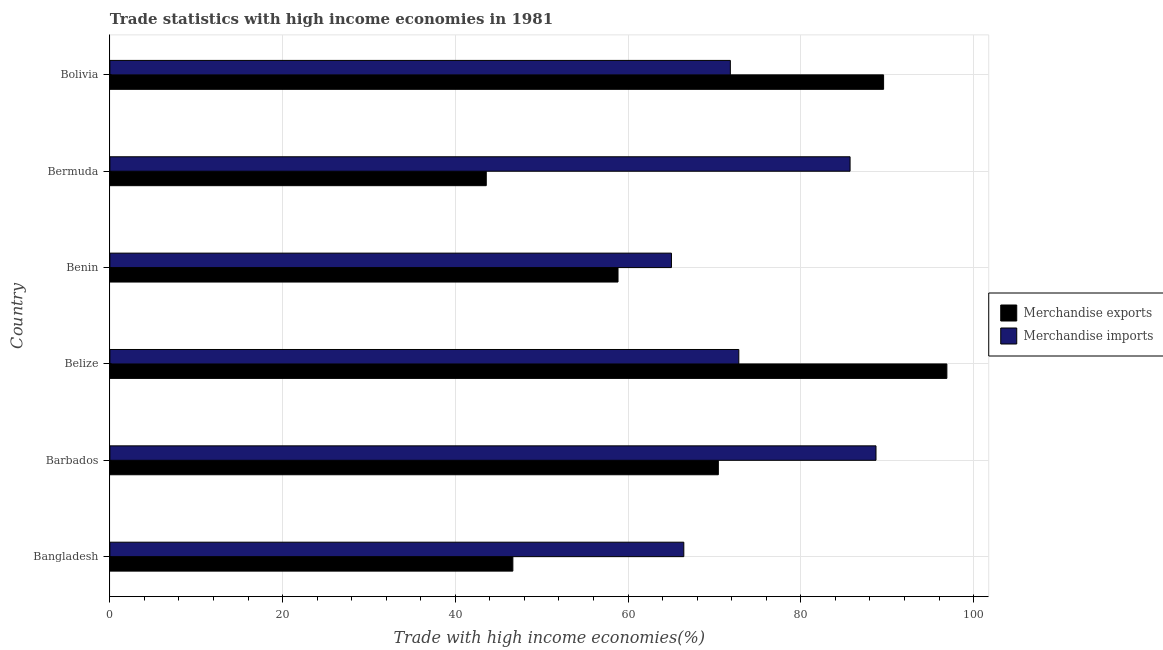How many groups of bars are there?
Give a very brief answer. 6. Are the number of bars on each tick of the Y-axis equal?
Provide a succinct answer. Yes. How many bars are there on the 1st tick from the bottom?
Offer a very short reply. 2. What is the label of the 1st group of bars from the top?
Offer a very short reply. Bolivia. In how many cases, is the number of bars for a given country not equal to the number of legend labels?
Your answer should be compact. 0. What is the merchandise imports in Bermuda?
Offer a terse response. 85.7. Across all countries, what is the maximum merchandise imports?
Give a very brief answer. 88.7. Across all countries, what is the minimum merchandise imports?
Ensure brevity in your answer.  65.02. In which country was the merchandise imports maximum?
Offer a very short reply. Barbados. In which country was the merchandise exports minimum?
Provide a short and direct response. Bermuda. What is the total merchandise exports in the graph?
Give a very brief answer. 406.02. What is the difference between the merchandise exports in Bangladesh and that in Belize?
Provide a short and direct response. -50.25. What is the difference between the merchandise imports in Benin and the merchandise exports in Belize?
Keep it short and to the point. -31.89. What is the average merchandise exports per country?
Your response must be concise. 67.67. What is the difference between the merchandise imports and merchandise exports in Barbados?
Your response must be concise. 18.25. What is the ratio of the merchandise imports in Barbados to that in Bolivia?
Ensure brevity in your answer.  1.24. Is the merchandise imports in Barbados less than that in Bolivia?
Provide a succinct answer. No. Is the difference between the merchandise exports in Belize and Bermuda greater than the difference between the merchandise imports in Belize and Bermuda?
Offer a very short reply. Yes. What is the difference between the highest and the second highest merchandise imports?
Provide a short and direct response. 3. What is the difference between the highest and the lowest merchandise imports?
Provide a short and direct response. 23.68. Is the sum of the merchandise imports in Bangladesh and Bolivia greater than the maximum merchandise exports across all countries?
Keep it short and to the point. Yes. What does the 2nd bar from the top in Barbados represents?
Ensure brevity in your answer.  Merchandise exports. How many bars are there?
Ensure brevity in your answer.  12. Are all the bars in the graph horizontal?
Provide a short and direct response. Yes. How many countries are there in the graph?
Your response must be concise. 6. Are the values on the major ticks of X-axis written in scientific E-notation?
Keep it short and to the point. No. Where does the legend appear in the graph?
Make the answer very short. Center right. How many legend labels are there?
Your response must be concise. 2. What is the title of the graph?
Provide a succinct answer. Trade statistics with high income economies in 1981. Does "Non-resident workers" appear as one of the legend labels in the graph?
Your answer should be compact. No. What is the label or title of the X-axis?
Provide a short and direct response. Trade with high income economies(%). What is the label or title of the Y-axis?
Your answer should be very brief. Country. What is the Trade with high income economies(%) in Merchandise exports in Bangladesh?
Offer a very short reply. 46.66. What is the Trade with high income economies(%) in Merchandise imports in Bangladesh?
Make the answer very short. 66.45. What is the Trade with high income economies(%) in Merchandise exports in Barbados?
Provide a short and direct response. 70.45. What is the Trade with high income economies(%) of Merchandise imports in Barbados?
Provide a short and direct response. 88.7. What is the Trade with high income economies(%) in Merchandise exports in Belize?
Provide a succinct answer. 96.91. What is the Trade with high income economies(%) of Merchandise imports in Belize?
Make the answer very short. 72.82. What is the Trade with high income economies(%) in Merchandise exports in Benin?
Ensure brevity in your answer.  58.83. What is the Trade with high income economies(%) in Merchandise imports in Benin?
Offer a terse response. 65.02. What is the Trade with high income economies(%) of Merchandise exports in Bermuda?
Offer a very short reply. 43.58. What is the Trade with high income economies(%) of Merchandise imports in Bermuda?
Offer a terse response. 85.7. What is the Trade with high income economies(%) in Merchandise exports in Bolivia?
Keep it short and to the point. 89.58. What is the Trade with high income economies(%) of Merchandise imports in Bolivia?
Ensure brevity in your answer.  71.84. Across all countries, what is the maximum Trade with high income economies(%) in Merchandise exports?
Your answer should be very brief. 96.91. Across all countries, what is the maximum Trade with high income economies(%) of Merchandise imports?
Make the answer very short. 88.7. Across all countries, what is the minimum Trade with high income economies(%) of Merchandise exports?
Your response must be concise. 43.58. Across all countries, what is the minimum Trade with high income economies(%) in Merchandise imports?
Make the answer very short. 65.02. What is the total Trade with high income economies(%) in Merchandise exports in the graph?
Ensure brevity in your answer.  406.02. What is the total Trade with high income economies(%) of Merchandise imports in the graph?
Provide a short and direct response. 450.54. What is the difference between the Trade with high income economies(%) of Merchandise exports in Bangladesh and that in Barbados?
Give a very brief answer. -23.79. What is the difference between the Trade with high income economies(%) of Merchandise imports in Bangladesh and that in Barbados?
Your answer should be very brief. -22.25. What is the difference between the Trade with high income economies(%) of Merchandise exports in Bangladesh and that in Belize?
Keep it short and to the point. -50.25. What is the difference between the Trade with high income economies(%) of Merchandise imports in Bangladesh and that in Belize?
Offer a very short reply. -6.37. What is the difference between the Trade with high income economies(%) of Merchandise exports in Bangladesh and that in Benin?
Make the answer very short. -12.18. What is the difference between the Trade with high income economies(%) in Merchandise imports in Bangladesh and that in Benin?
Make the answer very short. 1.43. What is the difference between the Trade with high income economies(%) in Merchandise exports in Bangladesh and that in Bermuda?
Offer a terse response. 3.08. What is the difference between the Trade with high income economies(%) of Merchandise imports in Bangladesh and that in Bermuda?
Your answer should be very brief. -19.25. What is the difference between the Trade with high income economies(%) of Merchandise exports in Bangladesh and that in Bolivia?
Give a very brief answer. -42.93. What is the difference between the Trade with high income economies(%) of Merchandise imports in Bangladesh and that in Bolivia?
Your response must be concise. -5.39. What is the difference between the Trade with high income economies(%) in Merchandise exports in Barbados and that in Belize?
Keep it short and to the point. -26.46. What is the difference between the Trade with high income economies(%) in Merchandise imports in Barbados and that in Belize?
Give a very brief answer. 15.88. What is the difference between the Trade with high income economies(%) of Merchandise exports in Barbados and that in Benin?
Ensure brevity in your answer.  11.62. What is the difference between the Trade with high income economies(%) in Merchandise imports in Barbados and that in Benin?
Give a very brief answer. 23.68. What is the difference between the Trade with high income economies(%) of Merchandise exports in Barbados and that in Bermuda?
Offer a very short reply. 26.87. What is the difference between the Trade with high income economies(%) in Merchandise imports in Barbados and that in Bermuda?
Provide a short and direct response. 3. What is the difference between the Trade with high income economies(%) in Merchandise exports in Barbados and that in Bolivia?
Your response must be concise. -19.13. What is the difference between the Trade with high income economies(%) of Merchandise imports in Barbados and that in Bolivia?
Keep it short and to the point. 16.86. What is the difference between the Trade with high income economies(%) of Merchandise exports in Belize and that in Benin?
Your response must be concise. 38.08. What is the difference between the Trade with high income economies(%) in Merchandise imports in Belize and that in Benin?
Offer a very short reply. 7.8. What is the difference between the Trade with high income economies(%) of Merchandise exports in Belize and that in Bermuda?
Your response must be concise. 53.33. What is the difference between the Trade with high income economies(%) of Merchandise imports in Belize and that in Bermuda?
Ensure brevity in your answer.  -12.88. What is the difference between the Trade with high income economies(%) of Merchandise exports in Belize and that in Bolivia?
Give a very brief answer. 7.33. What is the difference between the Trade with high income economies(%) in Merchandise imports in Belize and that in Bolivia?
Offer a very short reply. 0.98. What is the difference between the Trade with high income economies(%) of Merchandise exports in Benin and that in Bermuda?
Your answer should be compact. 15.26. What is the difference between the Trade with high income economies(%) of Merchandise imports in Benin and that in Bermuda?
Your response must be concise. -20.68. What is the difference between the Trade with high income economies(%) of Merchandise exports in Benin and that in Bolivia?
Make the answer very short. -30.75. What is the difference between the Trade with high income economies(%) of Merchandise imports in Benin and that in Bolivia?
Your answer should be very brief. -6.82. What is the difference between the Trade with high income economies(%) of Merchandise exports in Bermuda and that in Bolivia?
Make the answer very short. -46.01. What is the difference between the Trade with high income economies(%) of Merchandise imports in Bermuda and that in Bolivia?
Provide a succinct answer. 13.86. What is the difference between the Trade with high income economies(%) of Merchandise exports in Bangladesh and the Trade with high income economies(%) of Merchandise imports in Barbados?
Your answer should be very brief. -42.05. What is the difference between the Trade with high income economies(%) in Merchandise exports in Bangladesh and the Trade with high income economies(%) in Merchandise imports in Belize?
Your answer should be compact. -26.16. What is the difference between the Trade with high income economies(%) in Merchandise exports in Bangladesh and the Trade with high income economies(%) in Merchandise imports in Benin?
Your response must be concise. -18.36. What is the difference between the Trade with high income economies(%) of Merchandise exports in Bangladesh and the Trade with high income economies(%) of Merchandise imports in Bermuda?
Ensure brevity in your answer.  -39.05. What is the difference between the Trade with high income economies(%) of Merchandise exports in Bangladesh and the Trade with high income economies(%) of Merchandise imports in Bolivia?
Offer a terse response. -25.18. What is the difference between the Trade with high income economies(%) of Merchandise exports in Barbados and the Trade with high income economies(%) of Merchandise imports in Belize?
Offer a terse response. -2.37. What is the difference between the Trade with high income economies(%) in Merchandise exports in Barbados and the Trade with high income economies(%) in Merchandise imports in Benin?
Offer a very short reply. 5.43. What is the difference between the Trade with high income economies(%) in Merchandise exports in Barbados and the Trade with high income economies(%) in Merchandise imports in Bermuda?
Your response must be concise. -15.25. What is the difference between the Trade with high income economies(%) of Merchandise exports in Barbados and the Trade with high income economies(%) of Merchandise imports in Bolivia?
Ensure brevity in your answer.  -1.39. What is the difference between the Trade with high income economies(%) in Merchandise exports in Belize and the Trade with high income economies(%) in Merchandise imports in Benin?
Keep it short and to the point. 31.89. What is the difference between the Trade with high income economies(%) of Merchandise exports in Belize and the Trade with high income economies(%) of Merchandise imports in Bermuda?
Make the answer very short. 11.21. What is the difference between the Trade with high income economies(%) in Merchandise exports in Belize and the Trade with high income economies(%) in Merchandise imports in Bolivia?
Give a very brief answer. 25.07. What is the difference between the Trade with high income economies(%) of Merchandise exports in Benin and the Trade with high income economies(%) of Merchandise imports in Bermuda?
Keep it short and to the point. -26.87. What is the difference between the Trade with high income economies(%) in Merchandise exports in Benin and the Trade with high income economies(%) in Merchandise imports in Bolivia?
Keep it short and to the point. -13.01. What is the difference between the Trade with high income economies(%) of Merchandise exports in Bermuda and the Trade with high income economies(%) of Merchandise imports in Bolivia?
Offer a terse response. -28.26. What is the average Trade with high income economies(%) of Merchandise exports per country?
Keep it short and to the point. 67.67. What is the average Trade with high income economies(%) in Merchandise imports per country?
Your response must be concise. 75.09. What is the difference between the Trade with high income economies(%) in Merchandise exports and Trade with high income economies(%) in Merchandise imports in Bangladesh?
Your answer should be very brief. -19.79. What is the difference between the Trade with high income economies(%) of Merchandise exports and Trade with high income economies(%) of Merchandise imports in Barbados?
Offer a terse response. -18.25. What is the difference between the Trade with high income economies(%) of Merchandise exports and Trade with high income economies(%) of Merchandise imports in Belize?
Offer a very short reply. 24.09. What is the difference between the Trade with high income economies(%) of Merchandise exports and Trade with high income economies(%) of Merchandise imports in Benin?
Your response must be concise. -6.19. What is the difference between the Trade with high income economies(%) in Merchandise exports and Trade with high income economies(%) in Merchandise imports in Bermuda?
Your answer should be compact. -42.12. What is the difference between the Trade with high income economies(%) in Merchandise exports and Trade with high income economies(%) in Merchandise imports in Bolivia?
Make the answer very short. 17.74. What is the ratio of the Trade with high income economies(%) in Merchandise exports in Bangladesh to that in Barbados?
Offer a terse response. 0.66. What is the ratio of the Trade with high income economies(%) of Merchandise imports in Bangladesh to that in Barbados?
Ensure brevity in your answer.  0.75. What is the ratio of the Trade with high income economies(%) of Merchandise exports in Bangladesh to that in Belize?
Ensure brevity in your answer.  0.48. What is the ratio of the Trade with high income economies(%) of Merchandise imports in Bangladesh to that in Belize?
Provide a short and direct response. 0.91. What is the ratio of the Trade with high income economies(%) in Merchandise exports in Bangladesh to that in Benin?
Your answer should be very brief. 0.79. What is the ratio of the Trade with high income economies(%) of Merchandise exports in Bangladesh to that in Bermuda?
Ensure brevity in your answer.  1.07. What is the ratio of the Trade with high income economies(%) of Merchandise imports in Bangladesh to that in Bermuda?
Keep it short and to the point. 0.78. What is the ratio of the Trade with high income economies(%) in Merchandise exports in Bangladesh to that in Bolivia?
Offer a very short reply. 0.52. What is the ratio of the Trade with high income economies(%) of Merchandise imports in Bangladesh to that in Bolivia?
Make the answer very short. 0.93. What is the ratio of the Trade with high income economies(%) of Merchandise exports in Barbados to that in Belize?
Offer a very short reply. 0.73. What is the ratio of the Trade with high income economies(%) of Merchandise imports in Barbados to that in Belize?
Make the answer very short. 1.22. What is the ratio of the Trade with high income economies(%) of Merchandise exports in Barbados to that in Benin?
Make the answer very short. 1.2. What is the ratio of the Trade with high income economies(%) of Merchandise imports in Barbados to that in Benin?
Offer a terse response. 1.36. What is the ratio of the Trade with high income economies(%) of Merchandise exports in Barbados to that in Bermuda?
Your answer should be very brief. 1.62. What is the ratio of the Trade with high income economies(%) of Merchandise imports in Barbados to that in Bermuda?
Your response must be concise. 1.03. What is the ratio of the Trade with high income economies(%) of Merchandise exports in Barbados to that in Bolivia?
Keep it short and to the point. 0.79. What is the ratio of the Trade with high income economies(%) of Merchandise imports in Barbados to that in Bolivia?
Give a very brief answer. 1.23. What is the ratio of the Trade with high income economies(%) in Merchandise exports in Belize to that in Benin?
Your response must be concise. 1.65. What is the ratio of the Trade with high income economies(%) of Merchandise imports in Belize to that in Benin?
Give a very brief answer. 1.12. What is the ratio of the Trade with high income economies(%) of Merchandise exports in Belize to that in Bermuda?
Offer a terse response. 2.22. What is the ratio of the Trade with high income economies(%) in Merchandise imports in Belize to that in Bermuda?
Keep it short and to the point. 0.85. What is the ratio of the Trade with high income economies(%) in Merchandise exports in Belize to that in Bolivia?
Provide a short and direct response. 1.08. What is the ratio of the Trade with high income economies(%) of Merchandise imports in Belize to that in Bolivia?
Provide a succinct answer. 1.01. What is the ratio of the Trade with high income economies(%) in Merchandise exports in Benin to that in Bermuda?
Your response must be concise. 1.35. What is the ratio of the Trade with high income economies(%) in Merchandise imports in Benin to that in Bermuda?
Your response must be concise. 0.76. What is the ratio of the Trade with high income economies(%) of Merchandise exports in Benin to that in Bolivia?
Ensure brevity in your answer.  0.66. What is the ratio of the Trade with high income economies(%) of Merchandise imports in Benin to that in Bolivia?
Your response must be concise. 0.91. What is the ratio of the Trade with high income economies(%) in Merchandise exports in Bermuda to that in Bolivia?
Offer a terse response. 0.49. What is the ratio of the Trade with high income economies(%) in Merchandise imports in Bermuda to that in Bolivia?
Offer a very short reply. 1.19. What is the difference between the highest and the second highest Trade with high income economies(%) of Merchandise exports?
Your response must be concise. 7.33. What is the difference between the highest and the second highest Trade with high income economies(%) of Merchandise imports?
Offer a very short reply. 3. What is the difference between the highest and the lowest Trade with high income economies(%) in Merchandise exports?
Your answer should be compact. 53.33. What is the difference between the highest and the lowest Trade with high income economies(%) in Merchandise imports?
Make the answer very short. 23.68. 